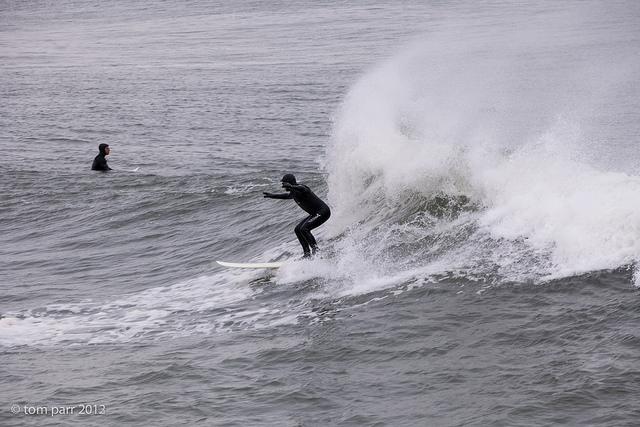What is the person riding?
Give a very brief answer. Surfboard. How many people are in the shot?
Be succinct. 2. What is the term for what the man is doing with his feet?
Be succinct. Hang 10. 